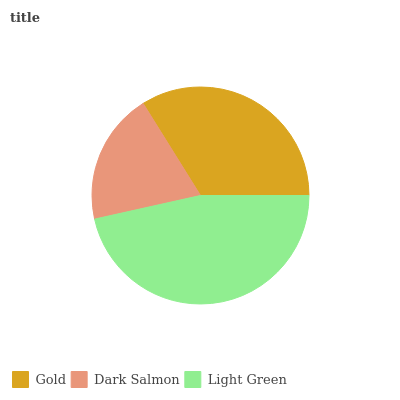Is Dark Salmon the minimum?
Answer yes or no. Yes. Is Light Green the maximum?
Answer yes or no. Yes. Is Light Green the minimum?
Answer yes or no. No. Is Dark Salmon the maximum?
Answer yes or no. No. Is Light Green greater than Dark Salmon?
Answer yes or no. Yes. Is Dark Salmon less than Light Green?
Answer yes or no. Yes. Is Dark Salmon greater than Light Green?
Answer yes or no. No. Is Light Green less than Dark Salmon?
Answer yes or no. No. Is Gold the high median?
Answer yes or no. Yes. Is Gold the low median?
Answer yes or no. Yes. Is Dark Salmon the high median?
Answer yes or no. No. Is Light Green the low median?
Answer yes or no. No. 